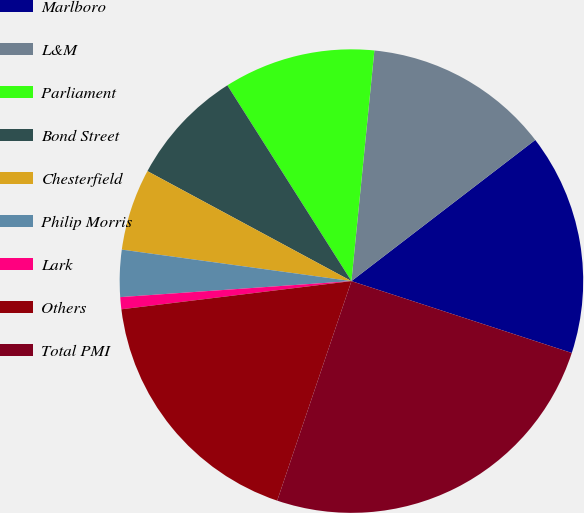Convert chart. <chart><loc_0><loc_0><loc_500><loc_500><pie_chart><fcel>Marlboro<fcel>L&M<fcel>Parliament<fcel>Bond Street<fcel>Chesterfield<fcel>Philip Morris<fcel>Lark<fcel>Others<fcel>Total PMI<nl><fcel>15.44%<fcel>13.0%<fcel>10.57%<fcel>8.14%<fcel>5.7%<fcel>3.27%<fcel>0.84%<fcel>17.87%<fcel>25.17%<nl></chart> 